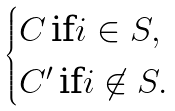<formula> <loc_0><loc_0><loc_500><loc_500>\begin{cases} C \, \text {if} i \in S , \\ C ^ { \prime } \, \text {if} i \not \in S . \end{cases}</formula> 